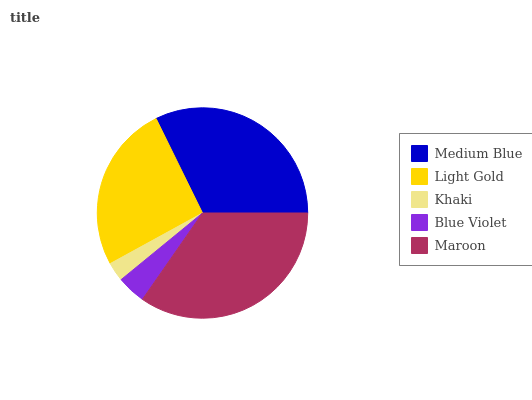Is Khaki the minimum?
Answer yes or no. Yes. Is Maroon the maximum?
Answer yes or no. Yes. Is Light Gold the minimum?
Answer yes or no. No. Is Light Gold the maximum?
Answer yes or no. No. Is Medium Blue greater than Light Gold?
Answer yes or no. Yes. Is Light Gold less than Medium Blue?
Answer yes or no. Yes. Is Light Gold greater than Medium Blue?
Answer yes or no. No. Is Medium Blue less than Light Gold?
Answer yes or no. No. Is Light Gold the high median?
Answer yes or no. Yes. Is Light Gold the low median?
Answer yes or no. Yes. Is Khaki the high median?
Answer yes or no. No. Is Medium Blue the low median?
Answer yes or no. No. 